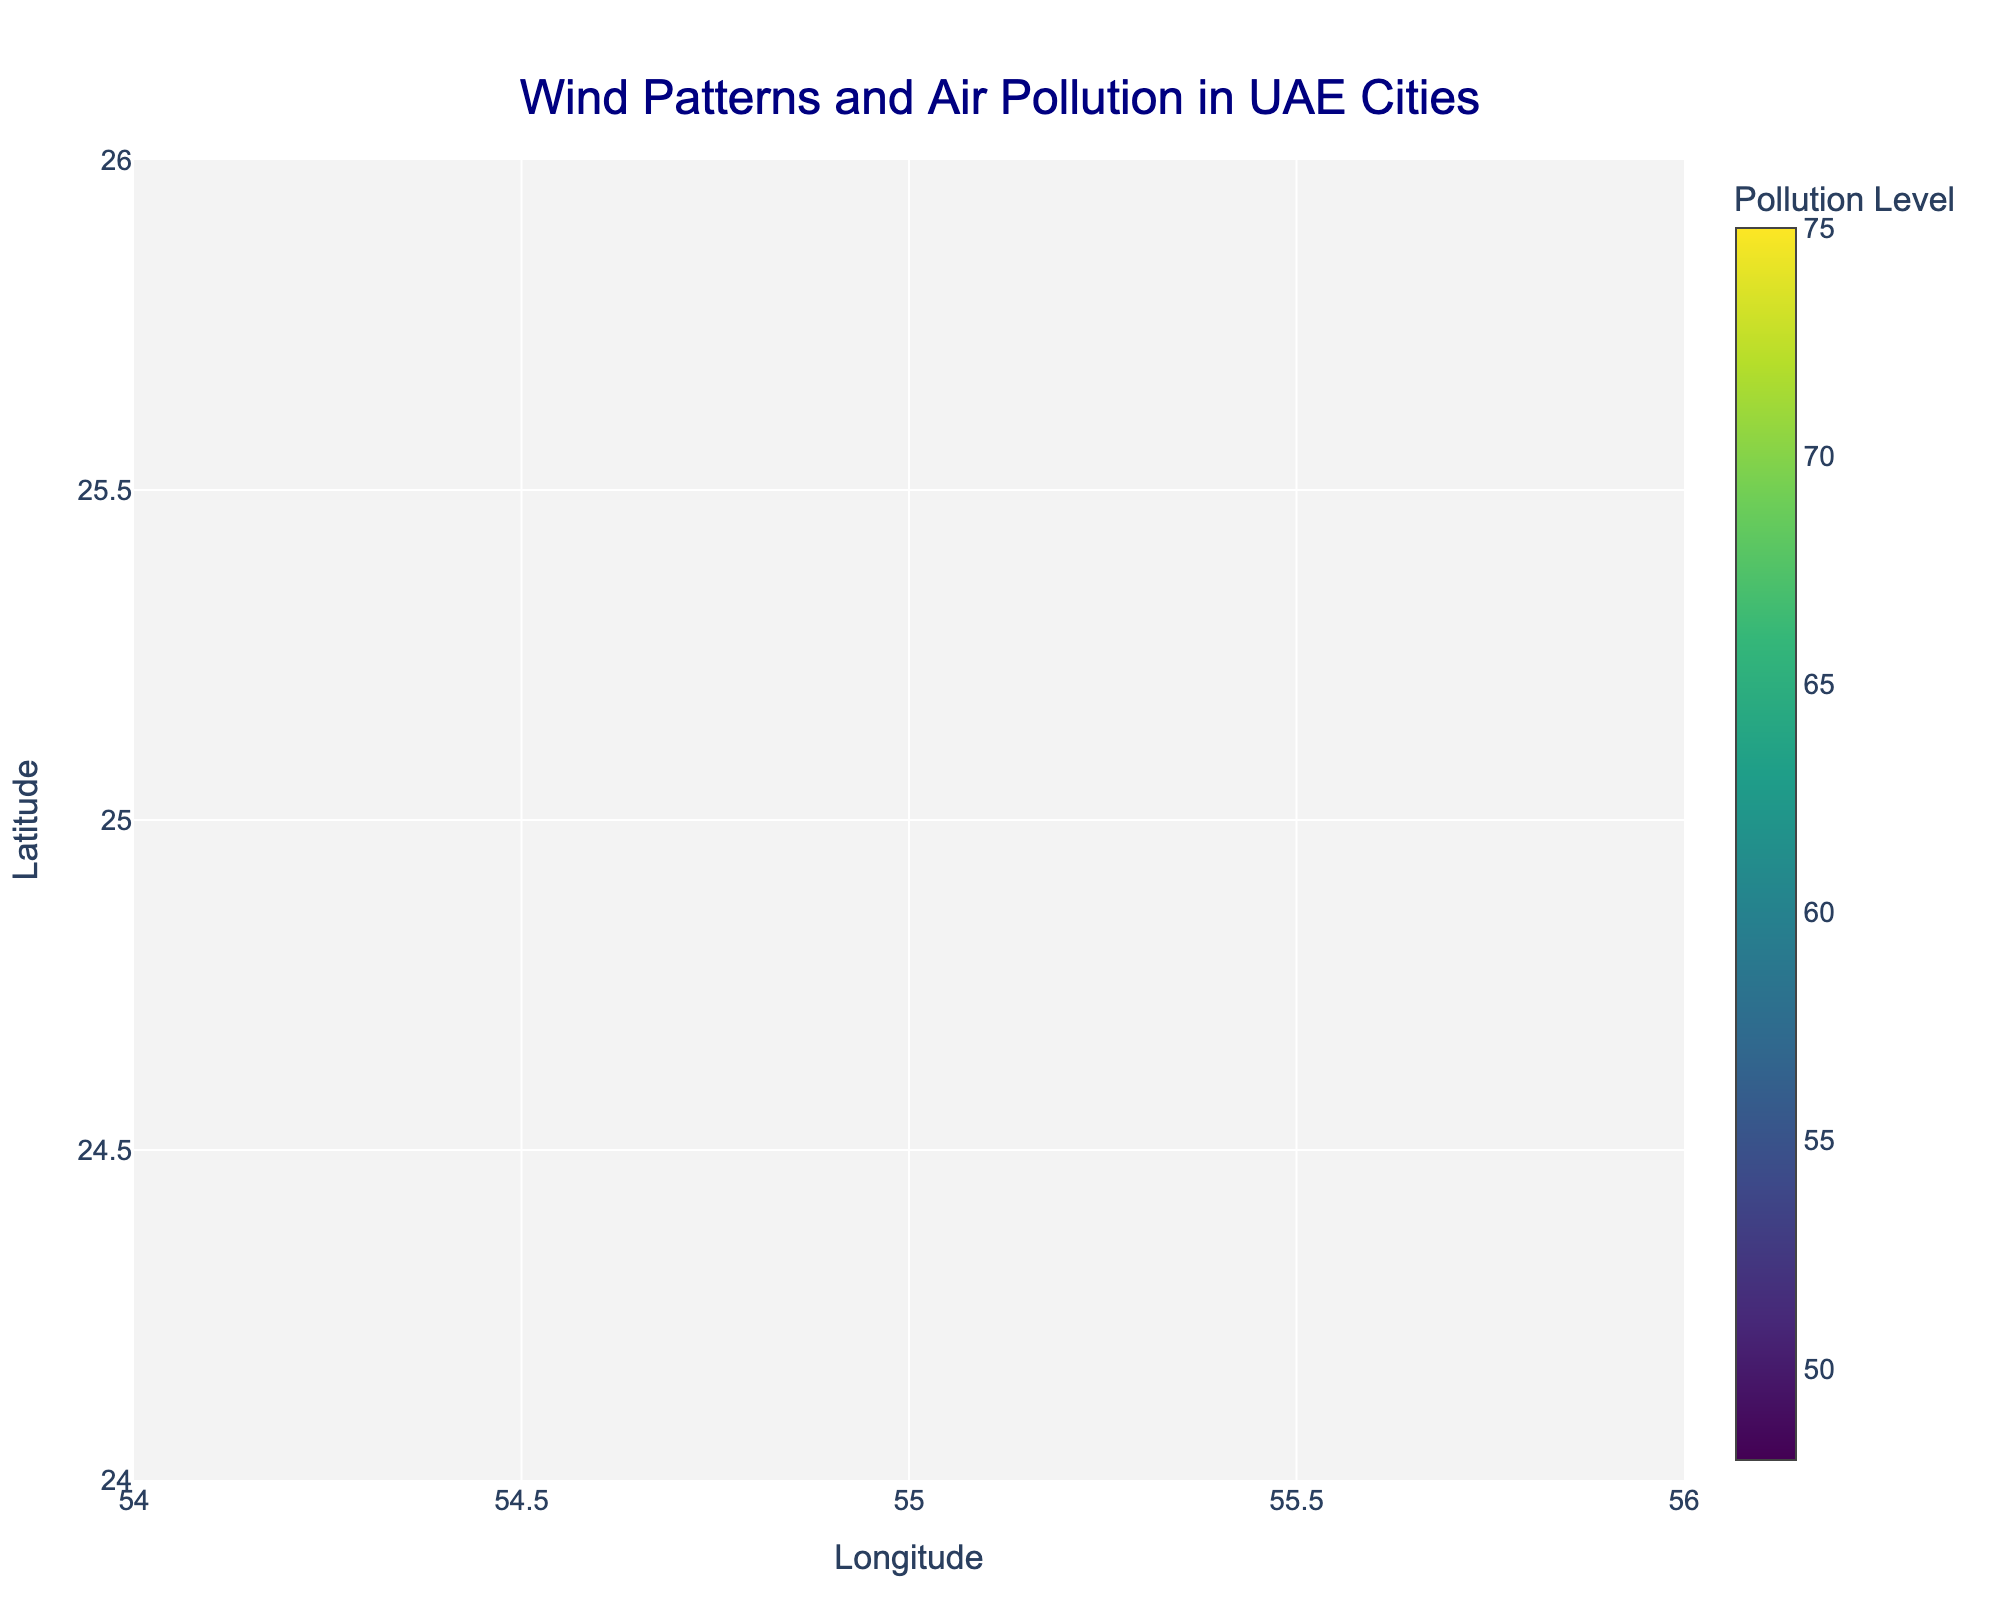what is the title of the figure? The title of the figure is usually positioned at the top center and often gives a clear indication of what the visualization is about. In this figure, it reads "Wind Patterns and Air Pollution in UAE Cities"
Answer: Wind Patterns and Air Pollution in UAE Cities Which city has the highest pollution level? From the figure, you can identify the highest pollution level by locating the largest and darkest colored marker. The hover text or color scale can help confirm this. Sharjah has the highest pollution level.
Answer: Sharjah How does the wind direction in Al Jimi compare to that in Al Maryah Island? Al Jimi shows a shorter arrow pointing left, indicating a milder wind blowing west. Comparatively, Al Maryah Island has a longer arrow pointing more steeply upward left, indicating a stronger wind blowing southwest.
Answer: Al Jimi has milder, westward wind; Al Maryah Island has stronger, southwestward wind What information is shown in the tooltip when hovering over a city marker? When you hover over a marker, it shows the city's name and its pollution level. For example, hovering over Abu Dhabi would display "Abu Dhabi<br>Pollution: 65" in the hover text.
Answer: The city's name and its pollution level How do the pollution levels of Al Reem Island and Downtown Dubai compare, and what is their difference? By referring to the size and color of the markers, as well as the hover text, you can see that Al Reem Island has a pollution level of 58 while Downtown Dubai's level is 70. The difference is calculated as 70 - 58 = 12.
Answer: Al Reem Island has a pollution level of 58 and Downtown Dubai has a level of 70; the difference is 12 What is the general direction of winds in major cities of UAE shown in the plot? Examining all the arrows, the wind generally blows towards the western or southwestern direction in all major UAE cities.
Answer: Western or southwestern direction What range of pollution levels is represented across these UAE cities? By observing the size and color scale of the markers, and using the color bar as a reference, pollution levels range from the lowest in Al Jimi (48) to the highest in Sharjah (75).
Answer: 48 to 75 Is there a visible correlation between wind strength and pollution levels in the figure? Inspecting the plot for markers with larger sizes and the corresponding wind arrows, it seems cities with higher pollution levels do not necessarily have stronger winds. Sharjah has the highest pollution with relatively moderate wind compared to other cities.
Answer: No clear correlation Which city has the weakest wind strength and how can you tell? The city with the weakest wind strength will have the shortest arrow. Al Reem Island shows an arrow with the shortest length, indicating the weakest wind.
Answer: Al Reem Island In which direction is the wind blowing in Dubai Marina? The direction of the wind can be determined by the orientation of the arrow. In Dubai Marina, the arrow points towards the left and slightly upwards, indicating the wind is blowing in a northwesterly direction.
Answer: Northwesterly direction 